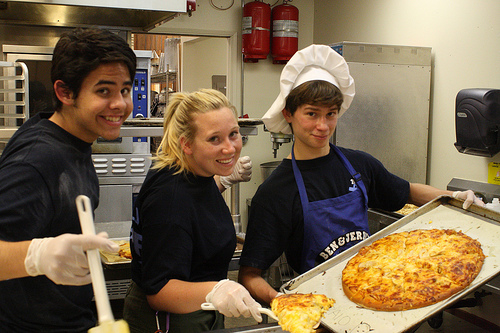Can you describe the expressions of the people? Certainly! The three people all show cheerful expressions, with smiles on their faces, indicating that they are enjoying the activity and each other's company. 